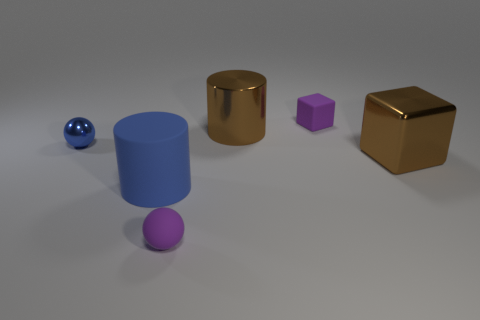Add 1 tiny metal objects. How many objects exist? 7 Subtract all spheres. How many objects are left? 4 Subtract all blue metallic objects. Subtract all large cyan things. How many objects are left? 5 Add 6 metal cylinders. How many metal cylinders are left? 7 Add 3 big metallic things. How many big metallic things exist? 5 Subtract 0 red cubes. How many objects are left? 6 